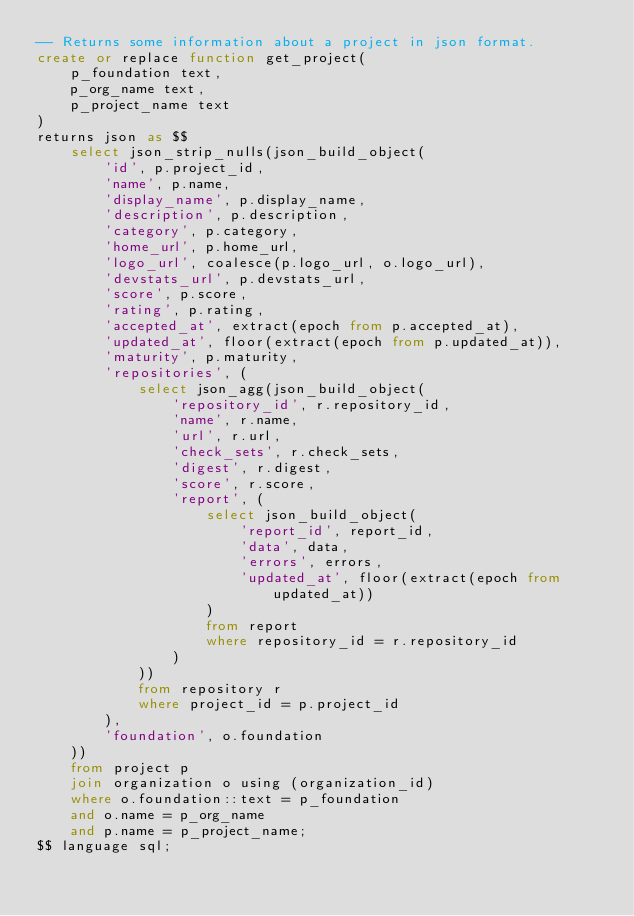<code> <loc_0><loc_0><loc_500><loc_500><_SQL_>-- Returns some information about a project in json format.
create or replace function get_project(
    p_foundation text,
    p_org_name text,
    p_project_name text
)
returns json as $$
    select json_strip_nulls(json_build_object(
        'id', p.project_id,
        'name', p.name,
        'display_name', p.display_name,
        'description', p.description,
        'category', p.category,
        'home_url', p.home_url,
        'logo_url', coalesce(p.logo_url, o.logo_url),
        'devstats_url', p.devstats_url,
        'score', p.score,
        'rating', p.rating,
        'accepted_at', extract(epoch from p.accepted_at),
        'updated_at', floor(extract(epoch from p.updated_at)),
        'maturity', p.maturity,
        'repositories', (
            select json_agg(json_build_object(
                'repository_id', r.repository_id,
                'name', r.name,
                'url', r.url,
                'check_sets', r.check_sets,
                'digest', r.digest,
                'score', r.score,
                'report', (
                    select json_build_object(
                        'report_id', report_id,
                        'data', data,
                        'errors', errors,
                        'updated_at', floor(extract(epoch from updated_at))
                    )
                    from report
                    where repository_id = r.repository_id
                )
            ))
            from repository r
            where project_id = p.project_id
        ),
        'foundation', o.foundation
    ))
    from project p
    join organization o using (organization_id)
    where o.foundation::text = p_foundation
    and o.name = p_org_name
    and p.name = p_project_name;
$$ language sql;
</code> 